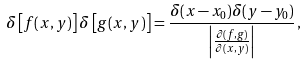Convert formula to latex. <formula><loc_0><loc_0><loc_500><loc_500>\delta \left [ f ( x , y ) \right ] \delta \left [ g ( x , y ) \right ] = \frac { \delta ( x - x _ { 0 } ) \delta ( y - y _ { 0 } ) } { \left | \frac { \partial ( f , g ) } { \partial ( x , y ) } \right | } \, ,</formula> 